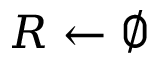<formula> <loc_0><loc_0><loc_500><loc_500>R \gets \emptyset</formula> 